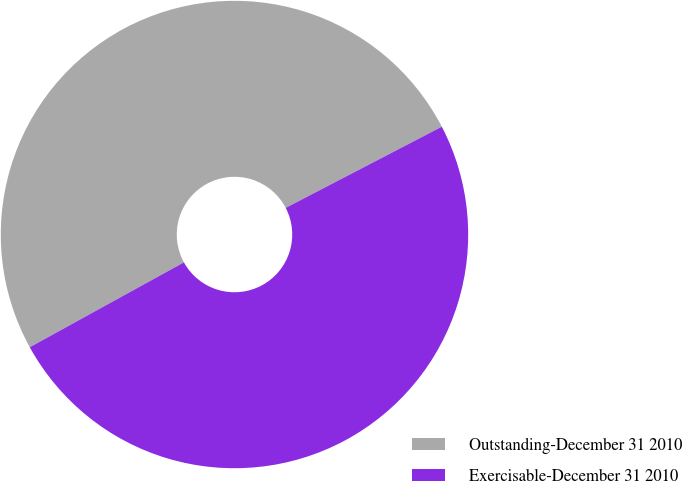Convert chart. <chart><loc_0><loc_0><loc_500><loc_500><pie_chart><fcel>Outstanding-December 31 2010<fcel>Exercisable-December 31 2010<nl><fcel>50.38%<fcel>49.62%<nl></chart> 